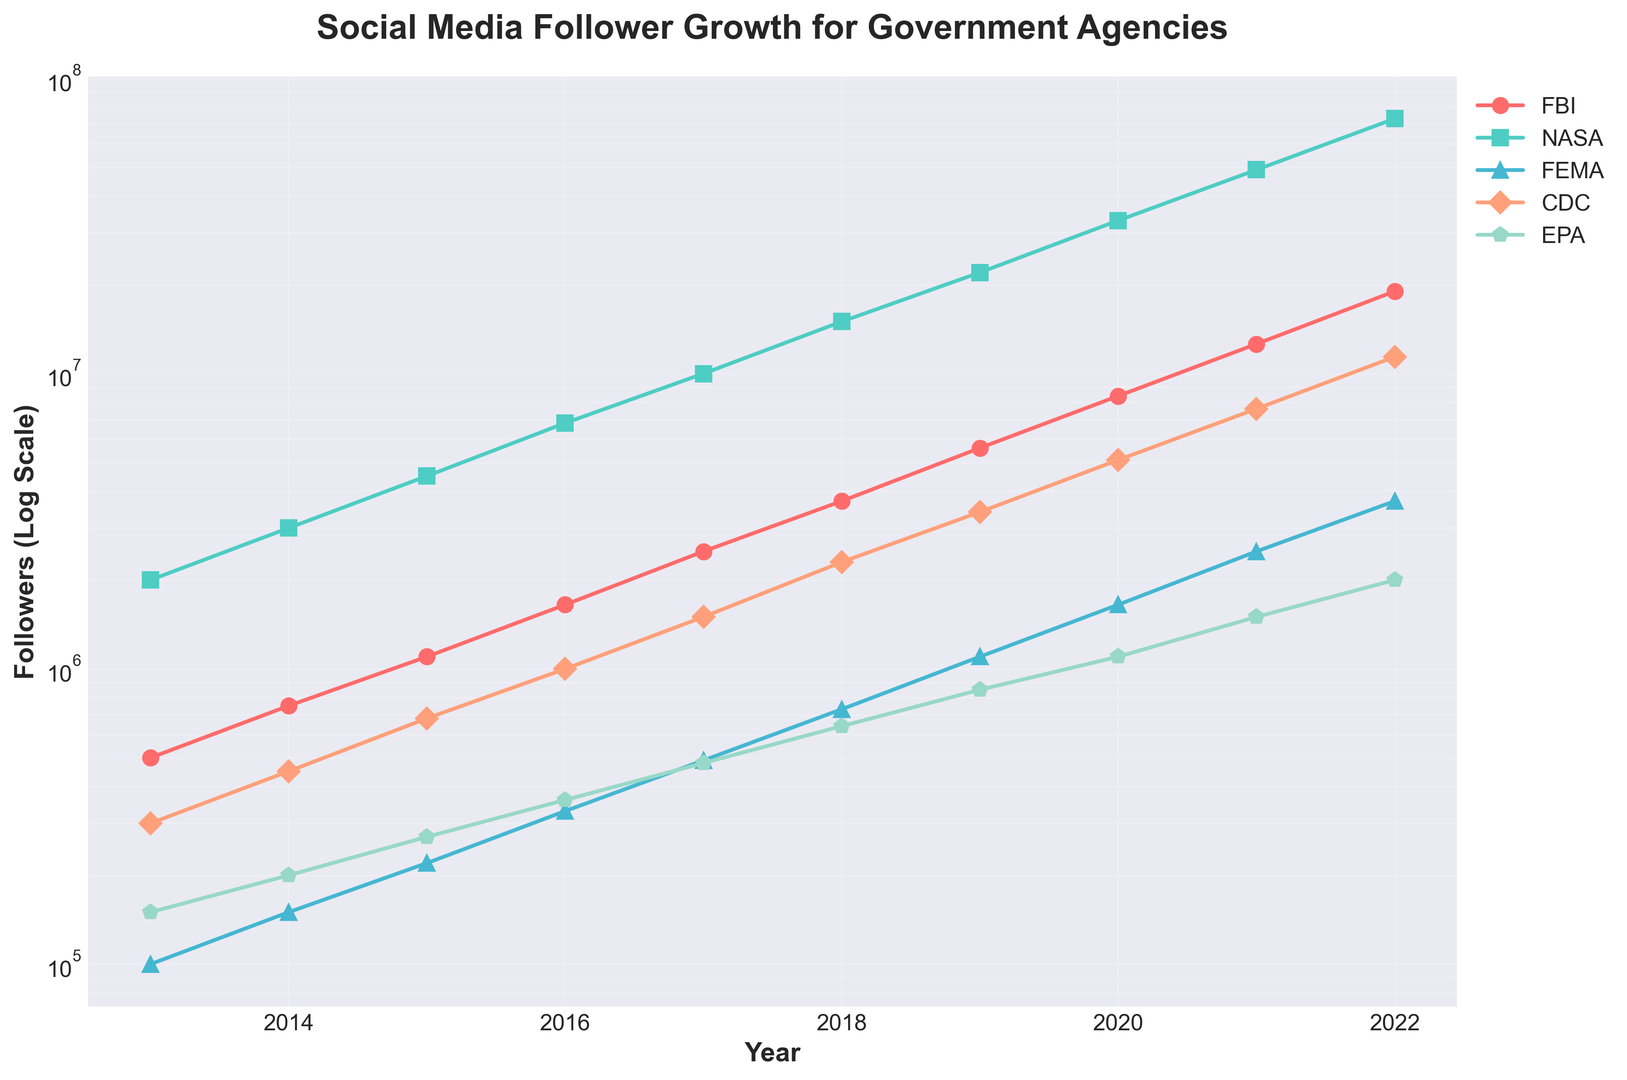What is the range of followers for NASA shown in the chart? To determine the range, find the minimum and maximum values for NASA from the figure. The minimum value in 2013 is 2,000,000 followers, and the maximum value in 2022 is 73,000,000 followers. Subtract the minimum from the maximum.
Answer: 71,000,000 followers Which agency had the least followers in 2013, and how many did it have? Look at the 2013 values for all agencies. The lowest follower count is for FEMA with 100,000 followers.
Answer: FEMA, 100,000 followers How many more followers did CDC have in 2020 compared to 2016? Find the follower count for CDC in both years. In 2020 it was 5,100,000 and in 2016 it was 1,000,000. Subtract the 2016 value from the 2020 value.
Answer: 4,100,000 followers By how many times did the EPA's followers increase from 2013 to 2022? Divide the value for EPA in 2022 (2,000,000) by the value in 2013 (150,000).
Answer: Approximately 13.33 times Which agency experienced the quickest growth in followers based on the steepness of the curve? Observe the steepest curve in the figure. NASA's curve is the steepest, indicating the quickest growth.
Answer: NASA In 2019, which agency had a higher number of followers: FEMA or EPA? Compare the values for FEMA and EPA in 2019. FEMA has 1,100,000 followers while EPA has 850,000 followers.
Answer: FEMA What was the average number of followers for FEMA from 2013 to 2022? Sum the follower counts for FEMA over the years (100,000 + 150,000 + 220,000 + 330,000 + 490,000 + 730,000 + 1,100,000 + 1,650,000 + 2,500,000 + 3,700,000) and divide by the number of years (10).
Answer: 997,000 followers Did the FBI ever surpass the CDC in follower count? If so, when? Compare the FBI and CDC follower counts year by year. The FBI surpassed CDC in 2013 and remained higher every year thereafter.
Answer: Yes, starting in 2013 Compare the follower growth trend between CDC and FEMA. Which agency shows more consistent growth? Observe the curves for CDC and FEMA. CDC's curve is steadier, indicating more consistent growth compared to FEMA.
Answer: CDC shows more consistent growth Which agency saw the smallest percentage increase in followers from 2013 to 2022? Calculate the percentage increase for each agency. The agency with the smallest increase is FBI, which went from 500,000 to 19,000,000, resulting in the smallest relative growth.
Answer: FBI 